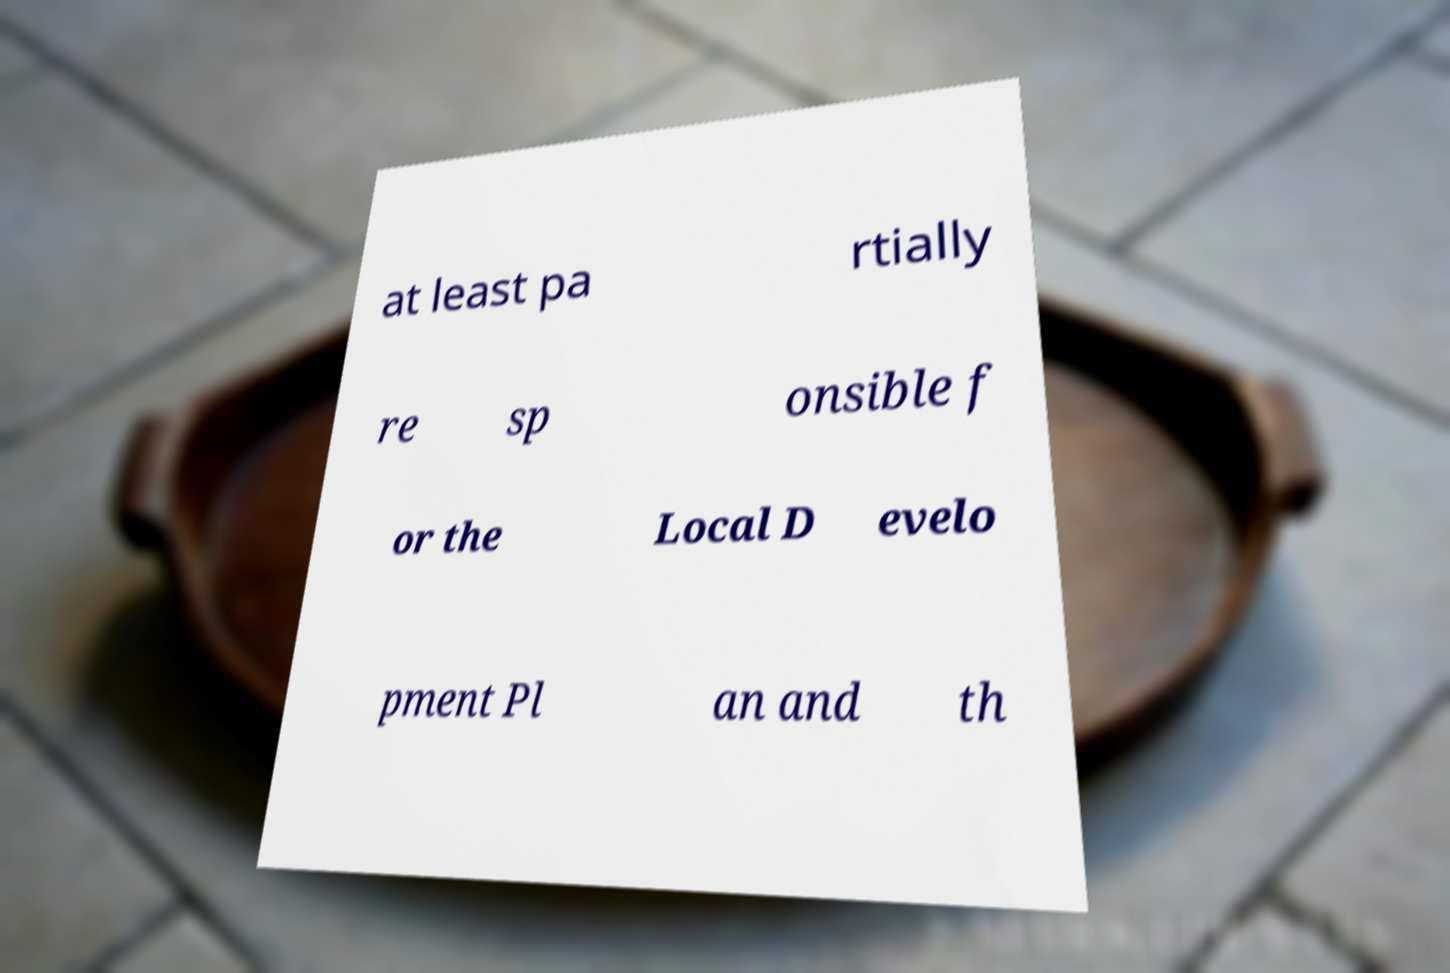What messages or text are displayed in this image? I need them in a readable, typed format. at least pa rtially re sp onsible f or the Local D evelo pment Pl an and th 